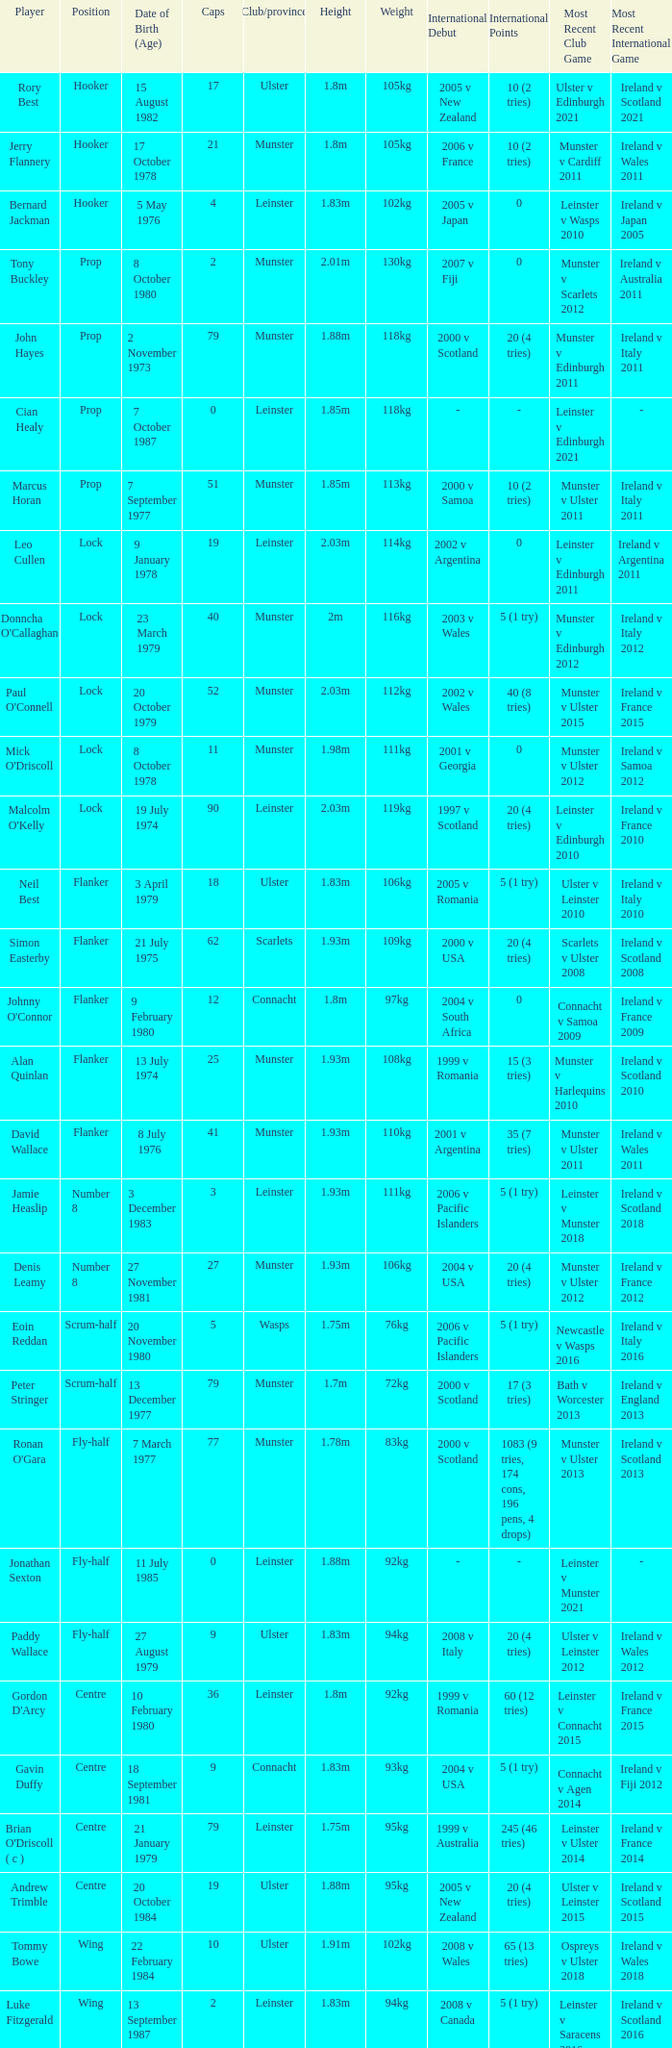What Club/province have caps less than 2 and Jonathan Sexton as player? Leinster. 